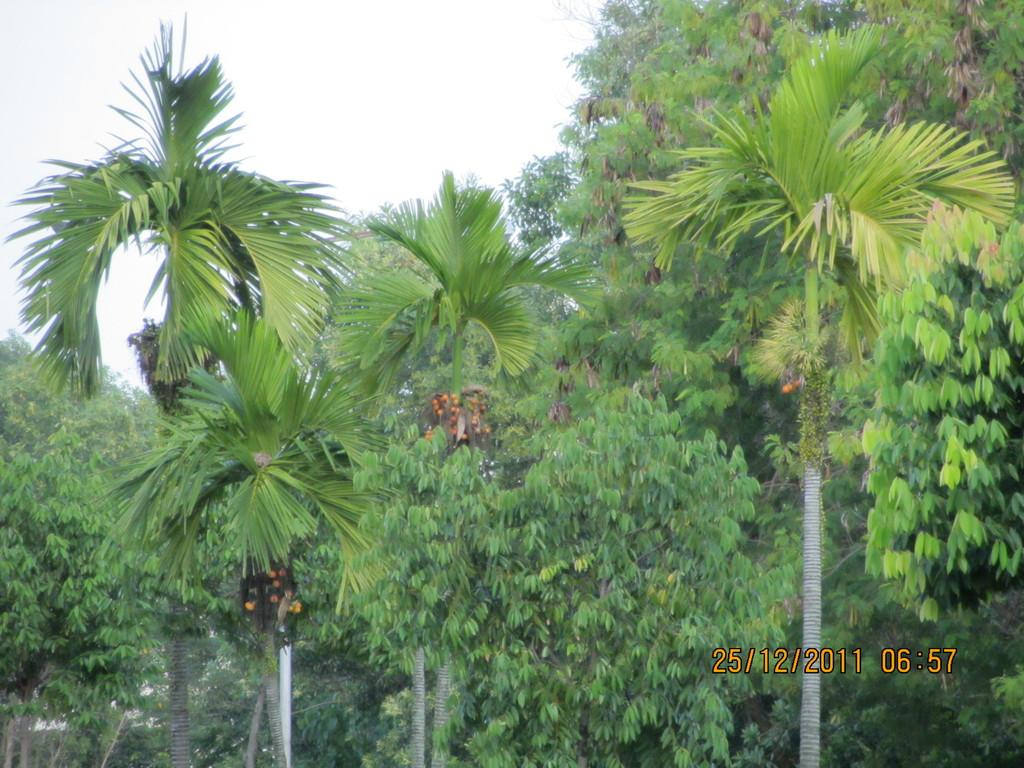What can be found in the right bottom corner of the image? There is a watermark in the right bottom corner of the image. What type of natural elements can be seen in the background of the image? There are trees in the background of the image. What else is visible in the background of the image? The sky is visible in the background of the image. What type of riddle can be seen hanging from the trees in the image? There is no riddle present in the image; it features a watermark and trees in the background. Can you see any bats flying in the sky in the image? There are no bats visible in the image; it only shows a watermark, trees, and the sky. 